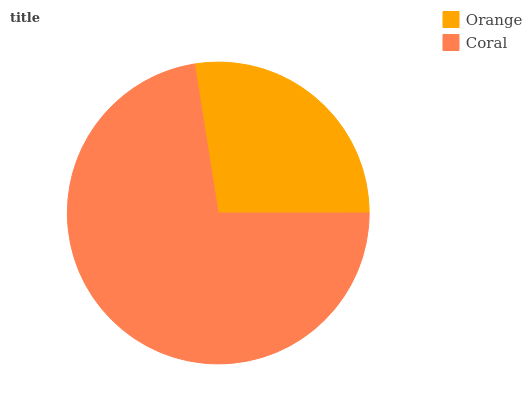Is Orange the minimum?
Answer yes or no. Yes. Is Coral the maximum?
Answer yes or no. Yes. Is Coral the minimum?
Answer yes or no. No. Is Coral greater than Orange?
Answer yes or no. Yes. Is Orange less than Coral?
Answer yes or no. Yes. Is Orange greater than Coral?
Answer yes or no. No. Is Coral less than Orange?
Answer yes or no. No. Is Coral the high median?
Answer yes or no. Yes. Is Orange the low median?
Answer yes or no. Yes. Is Orange the high median?
Answer yes or no. No. Is Coral the low median?
Answer yes or no. No. 